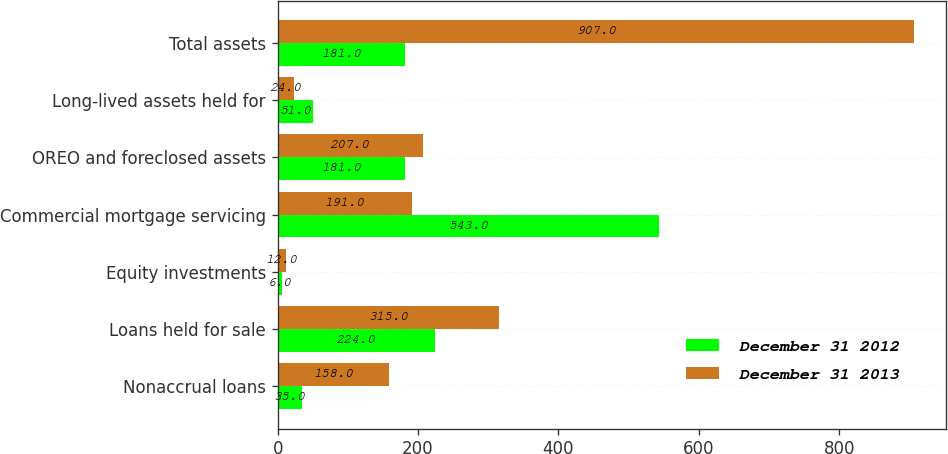<chart> <loc_0><loc_0><loc_500><loc_500><stacked_bar_chart><ecel><fcel>Nonaccrual loans<fcel>Loans held for sale<fcel>Equity investments<fcel>Commercial mortgage servicing<fcel>OREO and foreclosed assets<fcel>Long-lived assets held for<fcel>Total assets<nl><fcel>December 31 2012<fcel>35<fcel>224<fcel>6<fcel>543<fcel>181<fcel>51<fcel>181<nl><fcel>December 31 2013<fcel>158<fcel>315<fcel>12<fcel>191<fcel>207<fcel>24<fcel>907<nl></chart> 